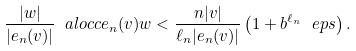Convert formula to latex. <formula><loc_0><loc_0><loc_500><loc_500>\frac { | w | } { | e _ { n } ( v ) | } \ a l o c c { e _ { n } ( v ) } { w } < \frac { n | v | } { \ell _ { n } | e _ { n } ( v ) | } \left ( 1 + b ^ { \ell _ { n } } \ e p s \right ) .</formula> 